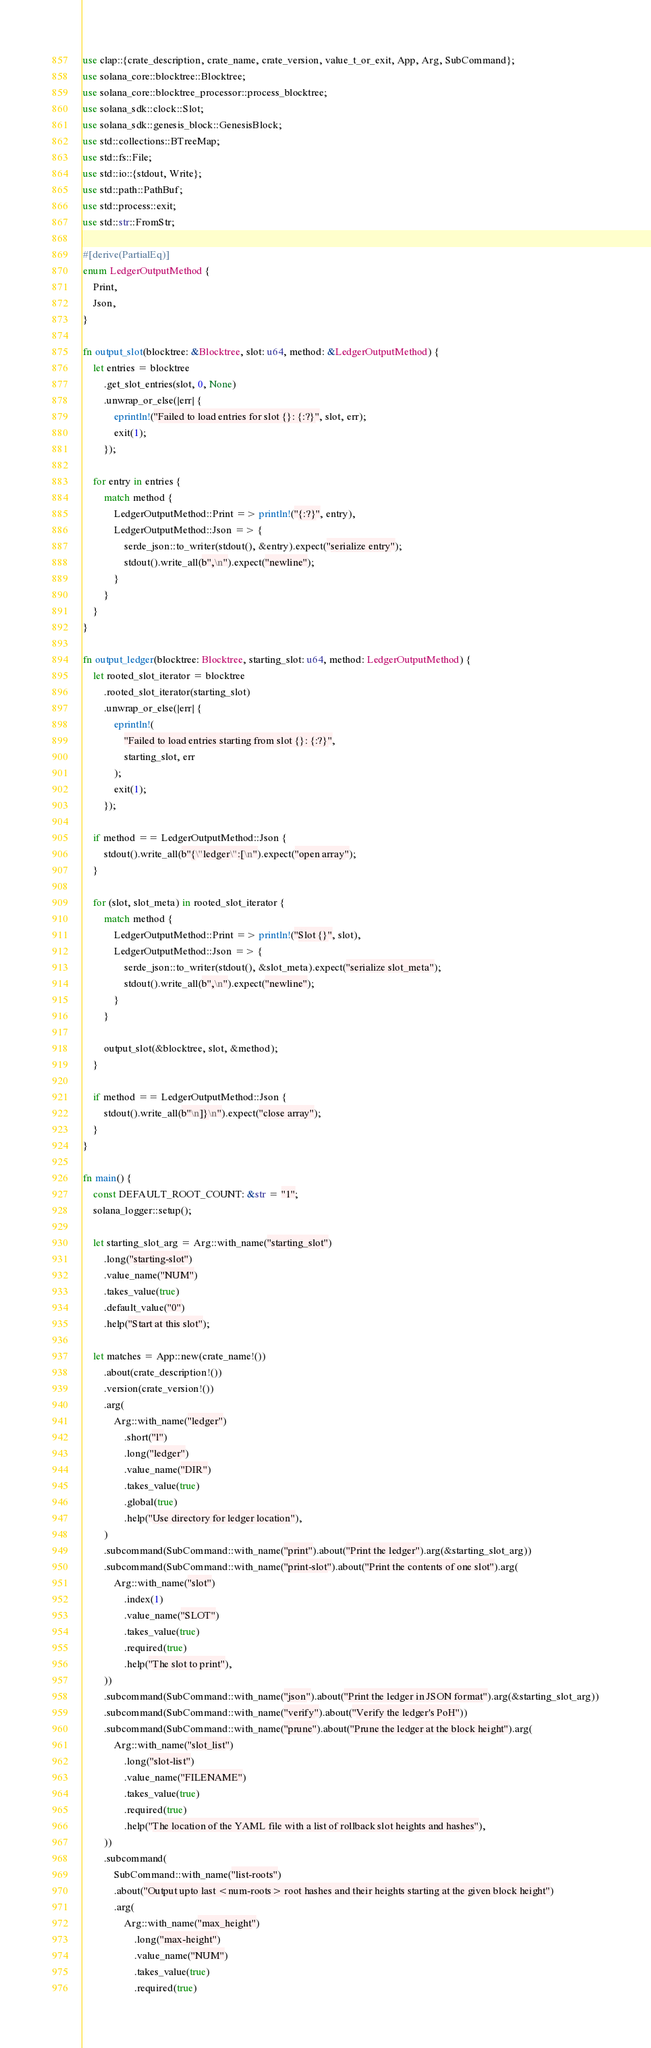<code> <loc_0><loc_0><loc_500><loc_500><_Rust_>use clap::{crate_description, crate_name, crate_version, value_t_or_exit, App, Arg, SubCommand};
use solana_core::blocktree::Blocktree;
use solana_core::blocktree_processor::process_blocktree;
use solana_sdk::clock::Slot;
use solana_sdk::genesis_block::GenesisBlock;
use std::collections::BTreeMap;
use std::fs::File;
use std::io::{stdout, Write};
use std::path::PathBuf;
use std::process::exit;
use std::str::FromStr;

#[derive(PartialEq)]
enum LedgerOutputMethod {
    Print,
    Json,
}

fn output_slot(blocktree: &Blocktree, slot: u64, method: &LedgerOutputMethod) {
    let entries = blocktree
        .get_slot_entries(slot, 0, None)
        .unwrap_or_else(|err| {
            eprintln!("Failed to load entries for slot {}: {:?}", slot, err);
            exit(1);
        });

    for entry in entries {
        match method {
            LedgerOutputMethod::Print => println!("{:?}", entry),
            LedgerOutputMethod::Json => {
                serde_json::to_writer(stdout(), &entry).expect("serialize entry");
                stdout().write_all(b",\n").expect("newline");
            }
        }
    }
}

fn output_ledger(blocktree: Blocktree, starting_slot: u64, method: LedgerOutputMethod) {
    let rooted_slot_iterator = blocktree
        .rooted_slot_iterator(starting_slot)
        .unwrap_or_else(|err| {
            eprintln!(
                "Failed to load entries starting from slot {}: {:?}",
                starting_slot, err
            );
            exit(1);
        });

    if method == LedgerOutputMethod::Json {
        stdout().write_all(b"{\"ledger\":[\n").expect("open array");
    }

    for (slot, slot_meta) in rooted_slot_iterator {
        match method {
            LedgerOutputMethod::Print => println!("Slot {}", slot),
            LedgerOutputMethod::Json => {
                serde_json::to_writer(stdout(), &slot_meta).expect("serialize slot_meta");
                stdout().write_all(b",\n").expect("newline");
            }
        }

        output_slot(&blocktree, slot, &method);
    }

    if method == LedgerOutputMethod::Json {
        stdout().write_all(b"\n]}\n").expect("close array");
    }
}

fn main() {
    const DEFAULT_ROOT_COUNT: &str = "1";
    solana_logger::setup();

    let starting_slot_arg = Arg::with_name("starting_slot")
        .long("starting-slot")
        .value_name("NUM")
        .takes_value(true)
        .default_value("0")
        .help("Start at this slot");

    let matches = App::new(crate_name!())
        .about(crate_description!())
        .version(crate_version!())
        .arg(
            Arg::with_name("ledger")
                .short("l")
                .long("ledger")
                .value_name("DIR")
                .takes_value(true)
                .global(true)
                .help("Use directory for ledger location"),
        )
        .subcommand(SubCommand::with_name("print").about("Print the ledger").arg(&starting_slot_arg))
        .subcommand(SubCommand::with_name("print-slot").about("Print the contents of one slot").arg(
            Arg::with_name("slot")
                .index(1)
                .value_name("SLOT")
                .takes_value(true)
                .required(true)
                .help("The slot to print"),
        ))
        .subcommand(SubCommand::with_name("json").about("Print the ledger in JSON format").arg(&starting_slot_arg))
        .subcommand(SubCommand::with_name("verify").about("Verify the ledger's PoH"))
        .subcommand(SubCommand::with_name("prune").about("Prune the ledger at the block height").arg(
            Arg::with_name("slot_list")
                .long("slot-list")
                .value_name("FILENAME")
                .takes_value(true)
                .required(true)
                .help("The location of the YAML file with a list of rollback slot heights and hashes"),
        ))
        .subcommand(
            SubCommand::with_name("list-roots")
            .about("Output upto last <num-roots> root hashes and their heights starting at the given block height")
            .arg(
                Arg::with_name("max_height")
                    .long("max-height")
                    .value_name("NUM")
                    .takes_value(true)
                    .required(true)</code> 